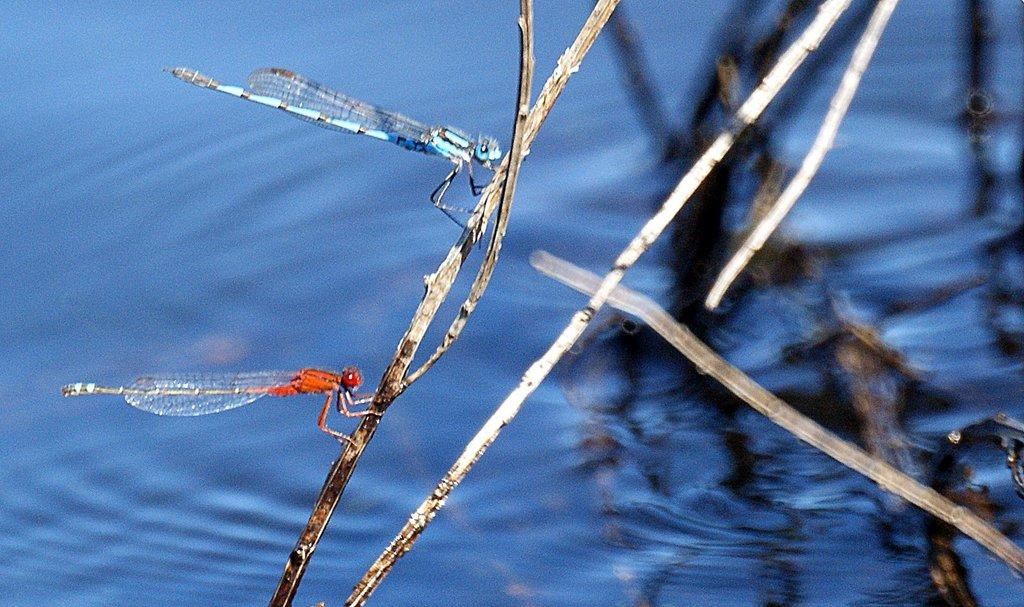What is located in the center of the image? There are dragonflies in the center of the image. How are the dragonflies positioned in the image? The dragonflies are on a stick. What can be seen in the background of the image? There is water visible in the background of the image. What else can be seen in the background of the image? There are sticks in the background of the image. What type of body is visible in the image? There is no body present in the image; it features dragonflies on a stick with water and sticks in the background. What belief is being represented in the image? There is no specific belief represented in the image; it simply shows dragonflies on a stick with a background of water and sticks. 